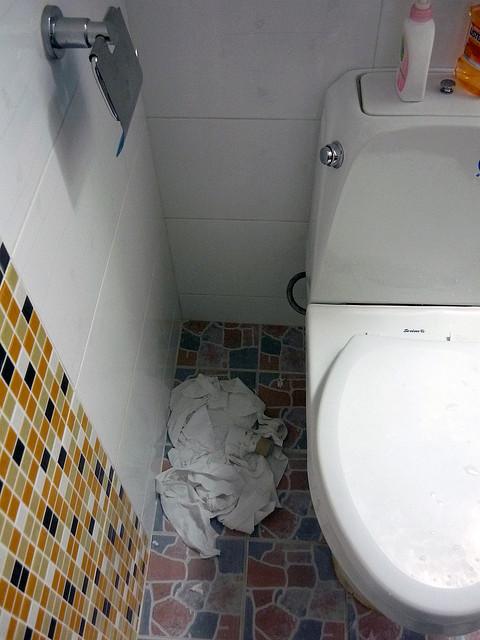Should somebody clean this up?
Write a very short answer. Yes. Is this floor messy?
Answer briefly. Yes. What color is the wall tile?
Give a very brief answer. White. 